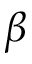<formula> <loc_0><loc_0><loc_500><loc_500>\beta</formula> 